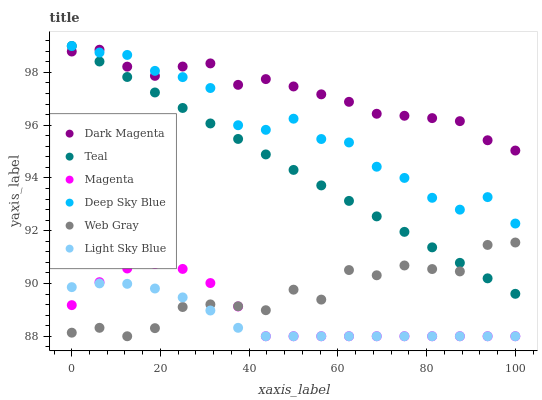Does Light Sky Blue have the minimum area under the curve?
Answer yes or no. Yes. Does Dark Magenta have the maximum area under the curve?
Answer yes or no. Yes. Does Web Gray have the minimum area under the curve?
Answer yes or no. No. Does Web Gray have the maximum area under the curve?
Answer yes or no. No. Is Teal the smoothest?
Answer yes or no. Yes. Is Web Gray the roughest?
Answer yes or no. Yes. Is Dark Magenta the smoothest?
Answer yes or no. No. Is Dark Magenta the roughest?
Answer yes or no. No. Does Web Gray have the lowest value?
Answer yes or no. Yes. Does Dark Magenta have the lowest value?
Answer yes or no. No. Does Deep Sky Blue have the highest value?
Answer yes or no. Yes. Does Web Gray have the highest value?
Answer yes or no. No. Is Web Gray less than Dark Magenta?
Answer yes or no. Yes. Is Dark Magenta greater than Light Sky Blue?
Answer yes or no. Yes. Does Light Sky Blue intersect Web Gray?
Answer yes or no. Yes. Is Light Sky Blue less than Web Gray?
Answer yes or no. No. Is Light Sky Blue greater than Web Gray?
Answer yes or no. No. Does Web Gray intersect Dark Magenta?
Answer yes or no. No. 